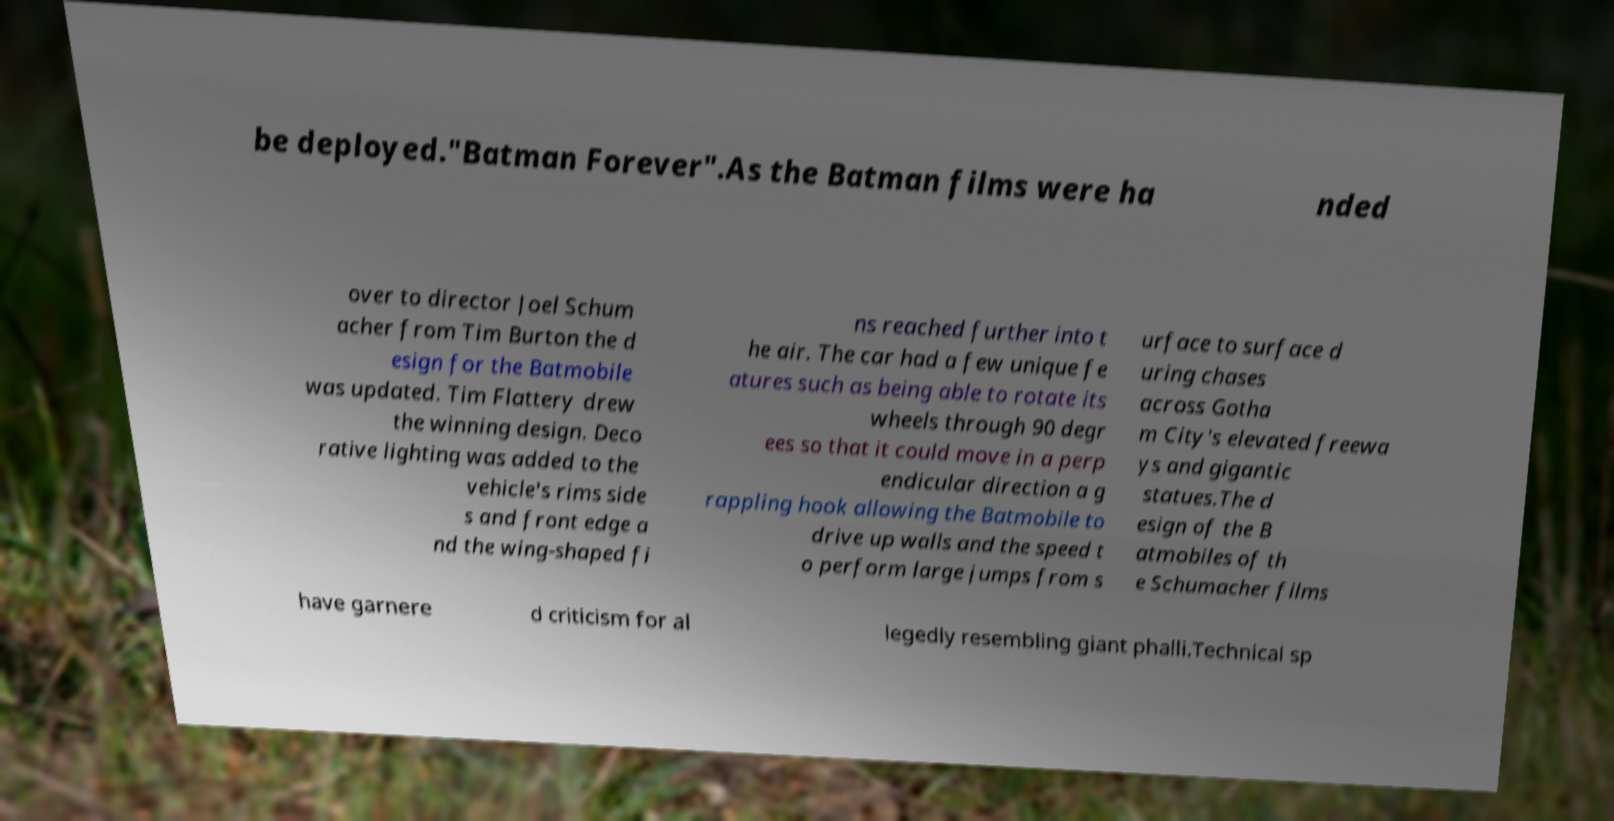Could you extract and type out the text from this image? be deployed."Batman Forever".As the Batman films were ha nded over to director Joel Schum acher from Tim Burton the d esign for the Batmobile was updated. Tim Flattery drew the winning design. Deco rative lighting was added to the vehicle's rims side s and front edge a nd the wing-shaped fi ns reached further into t he air. The car had a few unique fe atures such as being able to rotate its wheels through 90 degr ees so that it could move in a perp endicular direction a g rappling hook allowing the Batmobile to drive up walls and the speed t o perform large jumps from s urface to surface d uring chases across Gotha m City's elevated freewa ys and gigantic statues.The d esign of the B atmobiles of th e Schumacher films have garnere d criticism for al legedly resembling giant phalli.Technical sp 